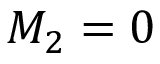<formula> <loc_0><loc_0><loc_500><loc_500>M _ { 2 } = 0</formula> 